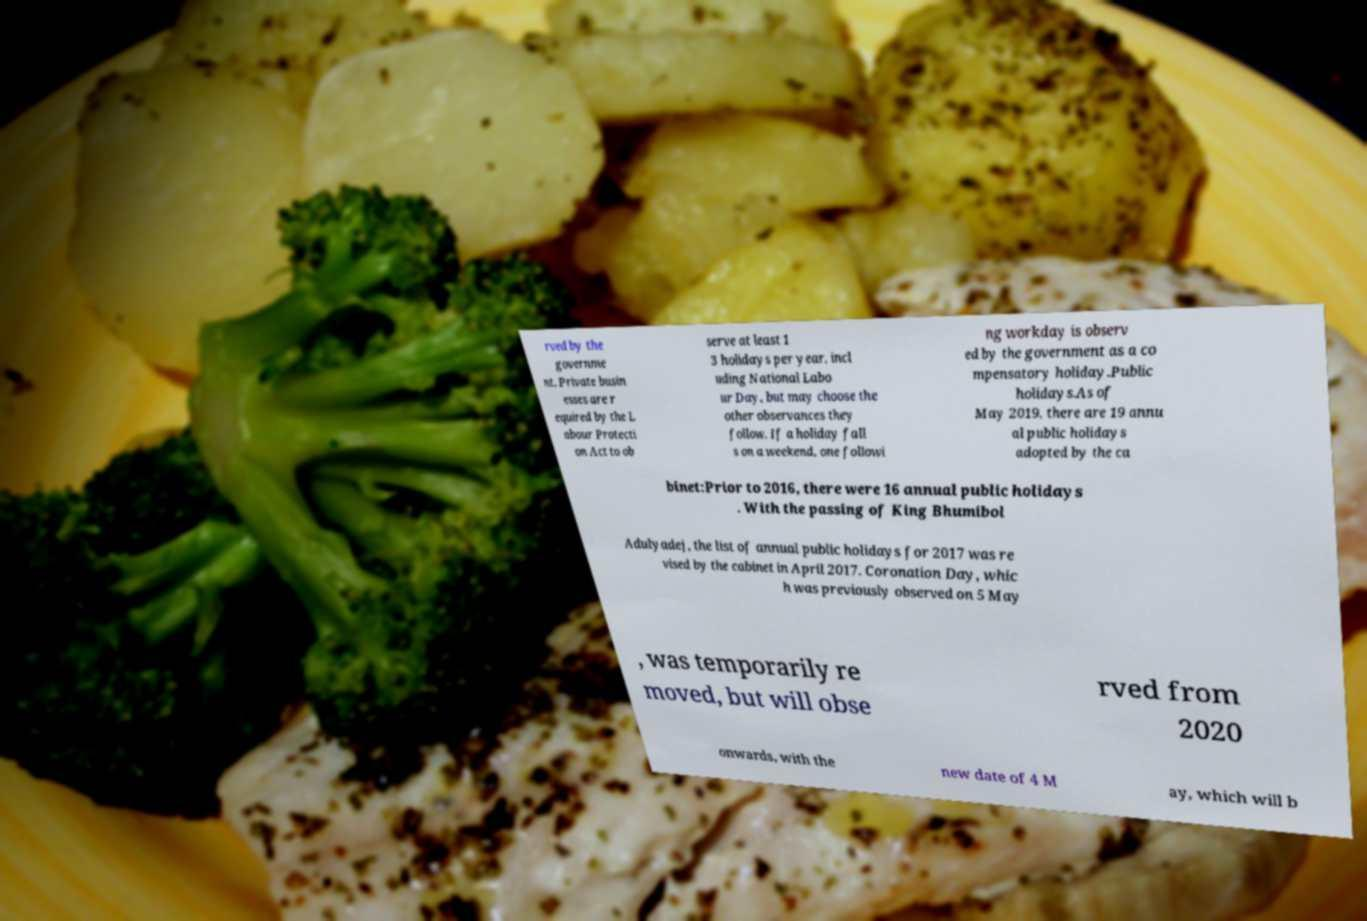There's text embedded in this image that I need extracted. Can you transcribe it verbatim? rved by the governme nt. Private busin esses are r equired by the L abour Protecti on Act to ob serve at least 1 3 holidays per year, incl uding National Labo ur Day, but may choose the other observances they follow. If a holiday fall s on a weekend, one followi ng workday is observ ed by the government as a co mpensatory holiday.Public holidays.As of May 2019, there are 19 annu al public holidays adopted by the ca binet:Prior to 2016, there were 16 annual public holidays . With the passing of King Bhumibol Adulyadej, the list of annual public holidays for 2017 was re vised by the cabinet in April 2017. Coronation Day, whic h was previously observed on 5 May , was temporarily re moved, but will obse rved from 2020 onwards, with the new date of 4 M ay, which will b 